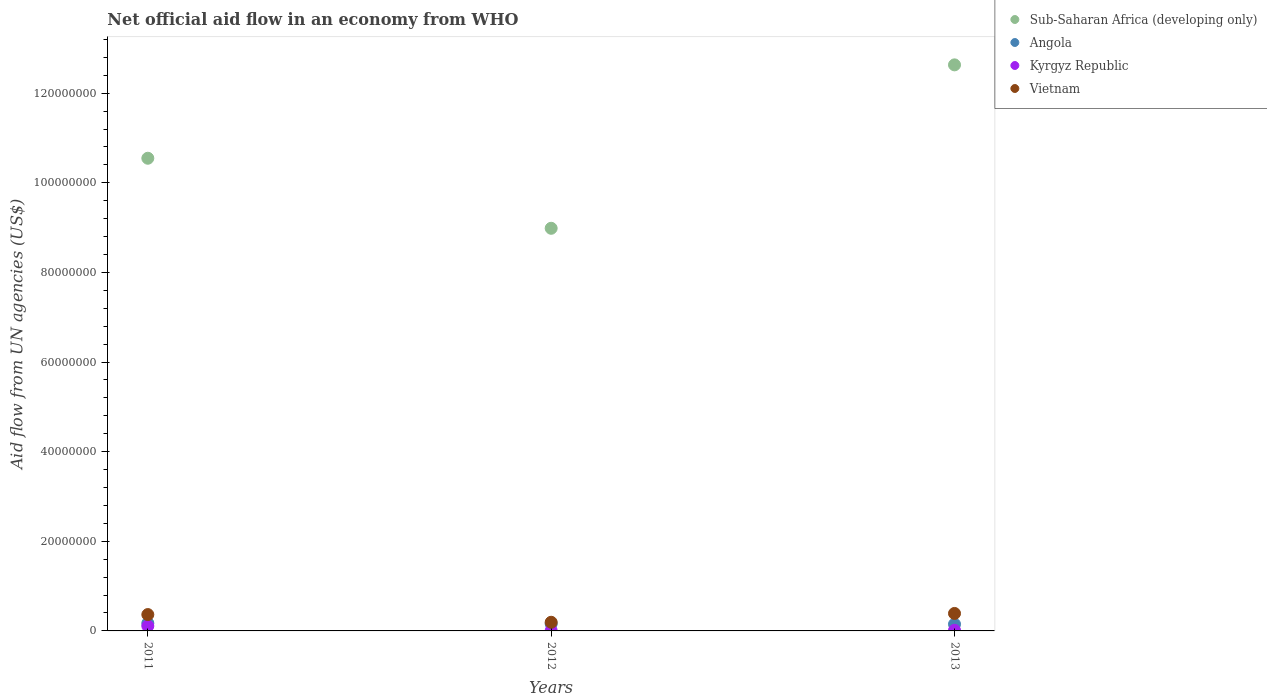How many different coloured dotlines are there?
Keep it short and to the point. 4. Across all years, what is the maximum net official aid flow in Angola?
Ensure brevity in your answer.  1.72e+06. Across all years, what is the minimum net official aid flow in Sub-Saharan Africa (developing only)?
Make the answer very short. 8.98e+07. In which year was the net official aid flow in Vietnam maximum?
Provide a short and direct response. 2013. What is the total net official aid flow in Angola in the graph?
Your answer should be very brief. 4.81e+06. What is the difference between the net official aid flow in Vietnam in 2011 and the net official aid flow in Kyrgyz Republic in 2013?
Offer a very short reply. 3.51e+06. What is the average net official aid flow in Kyrgyz Republic per year?
Offer a terse response. 4.37e+05. In the year 2012, what is the difference between the net official aid flow in Angola and net official aid flow in Vietnam?
Your answer should be very brief. -3.40e+05. In how many years, is the net official aid flow in Sub-Saharan Africa (developing only) greater than 96000000 US$?
Provide a short and direct response. 2. What is the ratio of the net official aid flow in Vietnam in 2011 to that in 2012?
Make the answer very short. 1.89. Is the difference between the net official aid flow in Angola in 2011 and 2012 greater than the difference between the net official aid flow in Vietnam in 2011 and 2012?
Give a very brief answer. No. What is the difference between the highest and the lowest net official aid flow in Vietnam?
Offer a very short reply. 1.97e+06. Is it the case that in every year, the sum of the net official aid flow in Angola and net official aid flow in Vietnam  is greater than the sum of net official aid flow in Kyrgyz Republic and net official aid flow in Sub-Saharan Africa (developing only)?
Your response must be concise. No. Is the net official aid flow in Kyrgyz Republic strictly less than the net official aid flow in Angola over the years?
Provide a short and direct response. Yes. How many dotlines are there?
Provide a succinct answer. 4. How many years are there in the graph?
Keep it short and to the point. 3. Are the values on the major ticks of Y-axis written in scientific E-notation?
Offer a very short reply. No. How are the legend labels stacked?
Your answer should be compact. Vertical. What is the title of the graph?
Make the answer very short. Net official aid flow in an economy from WHO. What is the label or title of the Y-axis?
Offer a terse response. Aid flow from UN agencies (US$). What is the Aid flow from UN agencies (US$) in Sub-Saharan Africa (developing only) in 2011?
Your answer should be very brief. 1.05e+08. What is the Aid flow from UN agencies (US$) in Angola in 2011?
Your answer should be compact. 1.72e+06. What is the Aid flow from UN agencies (US$) of Kyrgyz Republic in 2011?
Make the answer very short. 1.09e+06. What is the Aid flow from UN agencies (US$) in Vietnam in 2011?
Keep it short and to the point. 3.65e+06. What is the Aid flow from UN agencies (US$) of Sub-Saharan Africa (developing only) in 2012?
Your response must be concise. 8.98e+07. What is the Aid flow from UN agencies (US$) in Angola in 2012?
Your response must be concise. 1.59e+06. What is the Aid flow from UN agencies (US$) of Vietnam in 2012?
Your response must be concise. 1.93e+06. What is the Aid flow from UN agencies (US$) in Sub-Saharan Africa (developing only) in 2013?
Offer a terse response. 1.26e+08. What is the Aid flow from UN agencies (US$) in Angola in 2013?
Give a very brief answer. 1.50e+06. What is the Aid flow from UN agencies (US$) of Vietnam in 2013?
Provide a succinct answer. 3.90e+06. Across all years, what is the maximum Aid flow from UN agencies (US$) in Sub-Saharan Africa (developing only)?
Provide a short and direct response. 1.26e+08. Across all years, what is the maximum Aid flow from UN agencies (US$) of Angola?
Your answer should be very brief. 1.72e+06. Across all years, what is the maximum Aid flow from UN agencies (US$) in Kyrgyz Republic?
Your answer should be very brief. 1.09e+06. Across all years, what is the maximum Aid flow from UN agencies (US$) in Vietnam?
Your answer should be compact. 3.90e+06. Across all years, what is the minimum Aid flow from UN agencies (US$) in Sub-Saharan Africa (developing only)?
Offer a terse response. 8.98e+07. Across all years, what is the minimum Aid flow from UN agencies (US$) of Angola?
Offer a very short reply. 1.50e+06. Across all years, what is the minimum Aid flow from UN agencies (US$) of Kyrgyz Republic?
Offer a terse response. 8.00e+04. Across all years, what is the minimum Aid flow from UN agencies (US$) of Vietnam?
Provide a succinct answer. 1.93e+06. What is the total Aid flow from UN agencies (US$) in Sub-Saharan Africa (developing only) in the graph?
Provide a short and direct response. 3.22e+08. What is the total Aid flow from UN agencies (US$) of Angola in the graph?
Your answer should be very brief. 4.81e+06. What is the total Aid flow from UN agencies (US$) of Kyrgyz Republic in the graph?
Your answer should be very brief. 1.31e+06. What is the total Aid flow from UN agencies (US$) in Vietnam in the graph?
Give a very brief answer. 9.48e+06. What is the difference between the Aid flow from UN agencies (US$) in Sub-Saharan Africa (developing only) in 2011 and that in 2012?
Make the answer very short. 1.56e+07. What is the difference between the Aid flow from UN agencies (US$) of Kyrgyz Republic in 2011 and that in 2012?
Give a very brief answer. 1.01e+06. What is the difference between the Aid flow from UN agencies (US$) of Vietnam in 2011 and that in 2012?
Provide a succinct answer. 1.72e+06. What is the difference between the Aid flow from UN agencies (US$) in Sub-Saharan Africa (developing only) in 2011 and that in 2013?
Offer a very short reply. -2.08e+07. What is the difference between the Aid flow from UN agencies (US$) in Angola in 2011 and that in 2013?
Offer a very short reply. 2.20e+05. What is the difference between the Aid flow from UN agencies (US$) of Kyrgyz Republic in 2011 and that in 2013?
Your answer should be compact. 9.50e+05. What is the difference between the Aid flow from UN agencies (US$) in Vietnam in 2011 and that in 2013?
Provide a short and direct response. -2.50e+05. What is the difference between the Aid flow from UN agencies (US$) in Sub-Saharan Africa (developing only) in 2012 and that in 2013?
Your answer should be very brief. -3.65e+07. What is the difference between the Aid flow from UN agencies (US$) in Angola in 2012 and that in 2013?
Provide a short and direct response. 9.00e+04. What is the difference between the Aid flow from UN agencies (US$) in Vietnam in 2012 and that in 2013?
Your response must be concise. -1.97e+06. What is the difference between the Aid flow from UN agencies (US$) of Sub-Saharan Africa (developing only) in 2011 and the Aid flow from UN agencies (US$) of Angola in 2012?
Offer a very short reply. 1.04e+08. What is the difference between the Aid flow from UN agencies (US$) of Sub-Saharan Africa (developing only) in 2011 and the Aid flow from UN agencies (US$) of Kyrgyz Republic in 2012?
Your answer should be compact. 1.05e+08. What is the difference between the Aid flow from UN agencies (US$) in Sub-Saharan Africa (developing only) in 2011 and the Aid flow from UN agencies (US$) in Vietnam in 2012?
Offer a terse response. 1.04e+08. What is the difference between the Aid flow from UN agencies (US$) in Angola in 2011 and the Aid flow from UN agencies (US$) in Kyrgyz Republic in 2012?
Keep it short and to the point. 1.64e+06. What is the difference between the Aid flow from UN agencies (US$) in Kyrgyz Republic in 2011 and the Aid flow from UN agencies (US$) in Vietnam in 2012?
Make the answer very short. -8.40e+05. What is the difference between the Aid flow from UN agencies (US$) in Sub-Saharan Africa (developing only) in 2011 and the Aid flow from UN agencies (US$) in Angola in 2013?
Offer a terse response. 1.04e+08. What is the difference between the Aid flow from UN agencies (US$) of Sub-Saharan Africa (developing only) in 2011 and the Aid flow from UN agencies (US$) of Kyrgyz Republic in 2013?
Provide a succinct answer. 1.05e+08. What is the difference between the Aid flow from UN agencies (US$) of Sub-Saharan Africa (developing only) in 2011 and the Aid flow from UN agencies (US$) of Vietnam in 2013?
Provide a short and direct response. 1.02e+08. What is the difference between the Aid flow from UN agencies (US$) of Angola in 2011 and the Aid flow from UN agencies (US$) of Kyrgyz Republic in 2013?
Your answer should be compact. 1.58e+06. What is the difference between the Aid flow from UN agencies (US$) of Angola in 2011 and the Aid flow from UN agencies (US$) of Vietnam in 2013?
Your answer should be very brief. -2.18e+06. What is the difference between the Aid flow from UN agencies (US$) in Kyrgyz Republic in 2011 and the Aid flow from UN agencies (US$) in Vietnam in 2013?
Your answer should be very brief. -2.81e+06. What is the difference between the Aid flow from UN agencies (US$) of Sub-Saharan Africa (developing only) in 2012 and the Aid flow from UN agencies (US$) of Angola in 2013?
Provide a succinct answer. 8.84e+07. What is the difference between the Aid flow from UN agencies (US$) in Sub-Saharan Africa (developing only) in 2012 and the Aid flow from UN agencies (US$) in Kyrgyz Republic in 2013?
Give a very brief answer. 8.97e+07. What is the difference between the Aid flow from UN agencies (US$) of Sub-Saharan Africa (developing only) in 2012 and the Aid flow from UN agencies (US$) of Vietnam in 2013?
Your response must be concise. 8.60e+07. What is the difference between the Aid flow from UN agencies (US$) of Angola in 2012 and the Aid flow from UN agencies (US$) of Kyrgyz Republic in 2013?
Your answer should be very brief. 1.45e+06. What is the difference between the Aid flow from UN agencies (US$) in Angola in 2012 and the Aid flow from UN agencies (US$) in Vietnam in 2013?
Provide a short and direct response. -2.31e+06. What is the difference between the Aid flow from UN agencies (US$) of Kyrgyz Republic in 2012 and the Aid flow from UN agencies (US$) of Vietnam in 2013?
Keep it short and to the point. -3.82e+06. What is the average Aid flow from UN agencies (US$) in Sub-Saharan Africa (developing only) per year?
Offer a terse response. 1.07e+08. What is the average Aid flow from UN agencies (US$) of Angola per year?
Make the answer very short. 1.60e+06. What is the average Aid flow from UN agencies (US$) of Kyrgyz Republic per year?
Your answer should be compact. 4.37e+05. What is the average Aid flow from UN agencies (US$) in Vietnam per year?
Ensure brevity in your answer.  3.16e+06. In the year 2011, what is the difference between the Aid flow from UN agencies (US$) in Sub-Saharan Africa (developing only) and Aid flow from UN agencies (US$) in Angola?
Give a very brief answer. 1.04e+08. In the year 2011, what is the difference between the Aid flow from UN agencies (US$) in Sub-Saharan Africa (developing only) and Aid flow from UN agencies (US$) in Kyrgyz Republic?
Offer a very short reply. 1.04e+08. In the year 2011, what is the difference between the Aid flow from UN agencies (US$) in Sub-Saharan Africa (developing only) and Aid flow from UN agencies (US$) in Vietnam?
Make the answer very short. 1.02e+08. In the year 2011, what is the difference between the Aid flow from UN agencies (US$) of Angola and Aid flow from UN agencies (US$) of Kyrgyz Republic?
Provide a short and direct response. 6.30e+05. In the year 2011, what is the difference between the Aid flow from UN agencies (US$) in Angola and Aid flow from UN agencies (US$) in Vietnam?
Your answer should be compact. -1.93e+06. In the year 2011, what is the difference between the Aid flow from UN agencies (US$) of Kyrgyz Republic and Aid flow from UN agencies (US$) of Vietnam?
Offer a very short reply. -2.56e+06. In the year 2012, what is the difference between the Aid flow from UN agencies (US$) of Sub-Saharan Africa (developing only) and Aid flow from UN agencies (US$) of Angola?
Offer a very short reply. 8.83e+07. In the year 2012, what is the difference between the Aid flow from UN agencies (US$) of Sub-Saharan Africa (developing only) and Aid flow from UN agencies (US$) of Kyrgyz Republic?
Ensure brevity in your answer.  8.98e+07. In the year 2012, what is the difference between the Aid flow from UN agencies (US$) in Sub-Saharan Africa (developing only) and Aid flow from UN agencies (US$) in Vietnam?
Keep it short and to the point. 8.79e+07. In the year 2012, what is the difference between the Aid flow from UN agencies (US$) of Angola and Aid flow from UN agencies (US$) of Kyrgyz Republic?
Your response must be concise. 1.51e+06. In the year 2012, what is the difference between the Aid flow from UN agencies (US$) in Angola and Aid flow from UN agencies (US$) in Vietnam?
Give a very brief answer. -3.40e+05. In the year 2012, what is the difference between the Aid flow from UN agencies (US$) of Kyrgyz Republic and Aid flow from UN agencies (US$) of Vietnam?
Make the answer very short. -1.85e+06. In the year 2013, what is the difference between the Aid flow from UN agencies (US$) in Sub-Saharan Africa (developing only) and Aid flow from UN agencies (US$) in Angola?
Your response must be concise. 1.25e+08. In the year 2013, what is the difference between the Aid flow from UN agencies (US$) of Sub-Saharan Africa (developing only) and Aid flow from UN agencies (US$) of Kyrgyz Republic?
Give a very brief answer. 1.26e+08. In the year 2013, what is the difference between the Aid flow from UN agencies (US$) of Sub-Saharan Africa (developing only) and Aid flow from UN agencies (US$) of Vietnam?
Ensure brevity in your answer.  1.22e+08. In the year 2013, what is the difference between the Aid flow from UN agencies (US$) of Angola and Aid flow from UN agencies (US$) of Kyrgyz Republic?
Your response must be concise. 1.36e+06. In the year 2013, what is the difference between the Aid flow from UN agencies (US$) in Angola and Aid flow from UN agencies (US$) in Vietnam?
Ensure brevity in your answer.  -2.40e+06. In the year 2013, what is the difference between the Aid flow from UN agencies (US$) of Kyrgyz Republic and Aid flow from UN agencies (US$) of Vietnam?
Your answer should be compact. -3.76e+06. What is the ratio of the Aid flow from UN agencies (US$) of Sub-Saharan Africa (developing only) in 2011 to that in 2012?
Provide a succinct answer. 1.17. What is the ratio of the Aid flow from UN agencies (US$) in Angola in 2011 to that in 2012?
Offer a terse response. 1.08. What is the ratio of the Aid flow from UN agencies (US$) of Kyrgyz Republic in 2011 to that in 2012?
Your answer should be compact. 13.62. What is the ratio of the Aid flow from UN agencies (US$) in Vietnam in 2011 to that in 2012?
Give a very brief answer. 1.89. What is the ratio of the Aid flow from UN agencies (US$) of Sub-Saharan Africa (developing only) in 2011 to that in 2013?
Provide a short and direct response. 0.83. What is the ratio of the Aid flow from UN agencies (US$) of Angola in 2011 to that in 2013?
Keep it short and to the point. 1.15. What is the ratio of the Aid flow from UN agencies (US$) of Kyrgyz Republic in 2011 to that in 2013?
Offer a very short reply. 7.79. What is the ratio of the Aid flow from UN agencies (US$) of Vietnam in 2011 to that in 2013?
Give a very brief answer. 0.94. What is the ratio of the Aid flow from UN agencies (US$) of Sub-Saharan Africa (developing only) in 2012 to that in 2013?
Keep it short and to the point. 0.71. What is the ratio of the Aid flow from UN agencies (US$) in Angola in 2012 to that in 2013?
Offer a very short reply. 1.06. What is the ratio of the Aid flow from UN agencies (US$) in Vietnam in 2012 to that in 2013?
Offer a very short reply. 0.49. What is the difference between the highest and the second highest Aid flow from UN agencies (US$) of Sub-Saharan Africa (developing only)?
Give a very brief answer. 2.08e+07. What is the difference between the highest and the second highest Aid flow from UN agencies (US$) of Angola?
Keep it short and to the point. 1.30e+05. What is the difference between the highest and the second highest Aid flow from UN agencies (US$) in Kyrgyz Republic?
Your response must be concise. 9.50e+05. What is the difference between the highest and the second highest Aid flow from UN agencies (US$) of Vietnam?
Your answer should be very brief. 2.50e+05. What is the difference between the highest and the lowest Aid flow from UN agencies (US$) of Sub-Saharan Africa (developing only)?
Give a very brief answer. 3.65e+07. What is the difference between the highest and the lowest Aid flow from UN agencies (US$) of Kyrgyz Republic?
Provide a short and direct response. 1.01e+06. What is the difference between the highest and the lowest Aid flow from UN agencies (US$) of Vietnam?
Keep it short and to the point. 1.97e+06. 